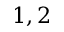Convert formula to latex. <formula><loc_0><loc_0><loc_500><loc_500>{ 1 , 2 }</formula> 